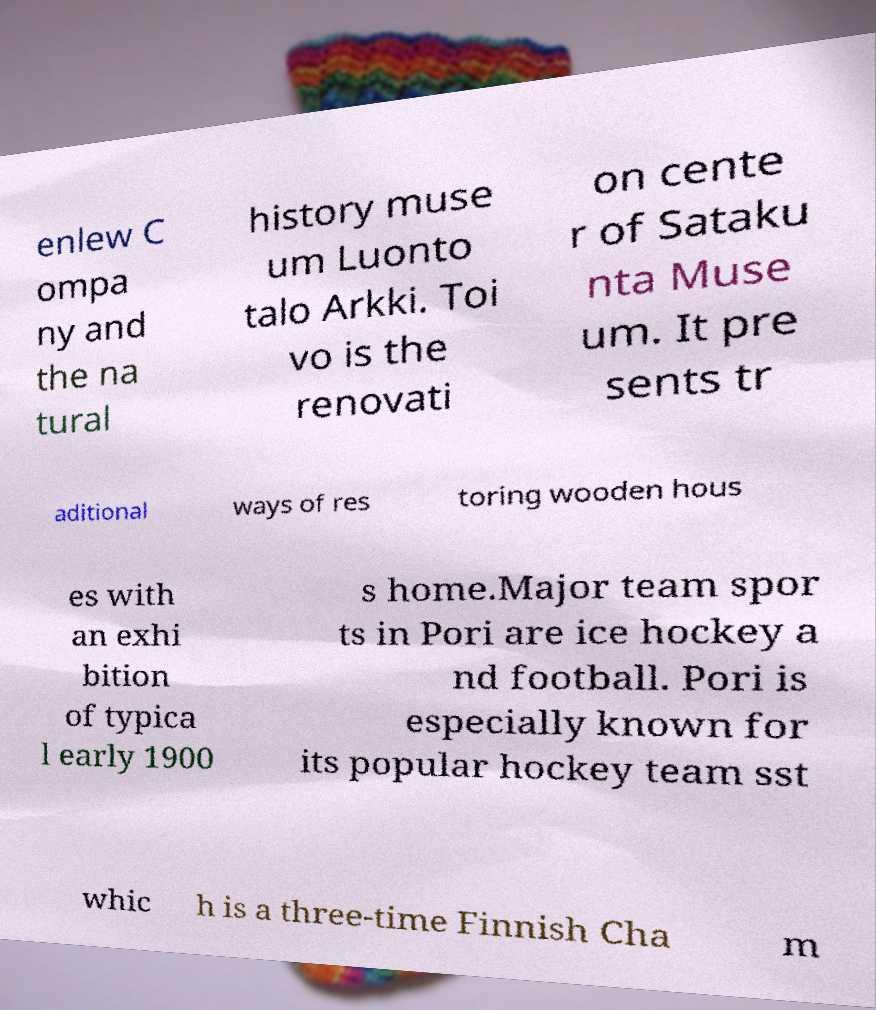There's text embedded in this image that I need extracted. Can you transcribe it verbatim? enlew C ompa ny and the na tural history muse um Luonto talo Arkki. Toi vo is the renovati on cente r of Sataku nta Muse um. It pre sents tr aditional ways of res toring wooden hous es with an exhi bition of typica l early 1900 s home.Major team spor ts in Pori are ice hockey a nd football. Pori is especially known for its popular hockey team sst whic h is a three-time Finnish Cha m 